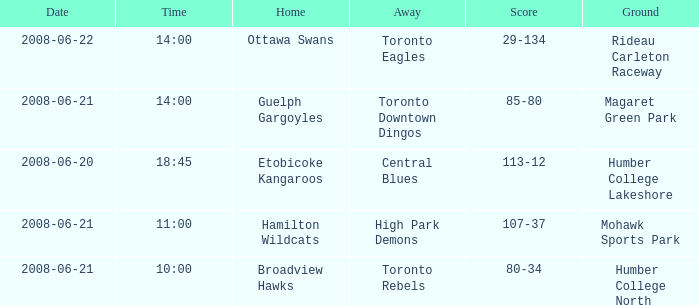What is the time when the score is between 80 and 34? 10:00. 